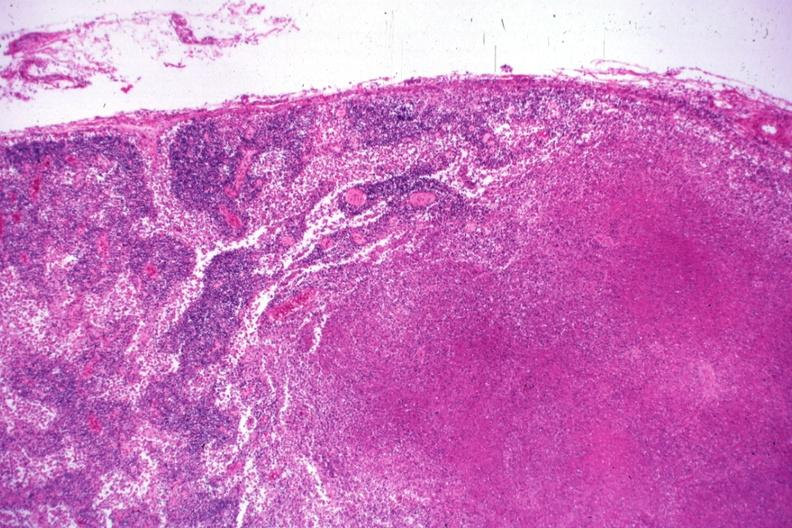s papillary adenoma present?
Answer the question using a single word or phrase. No 